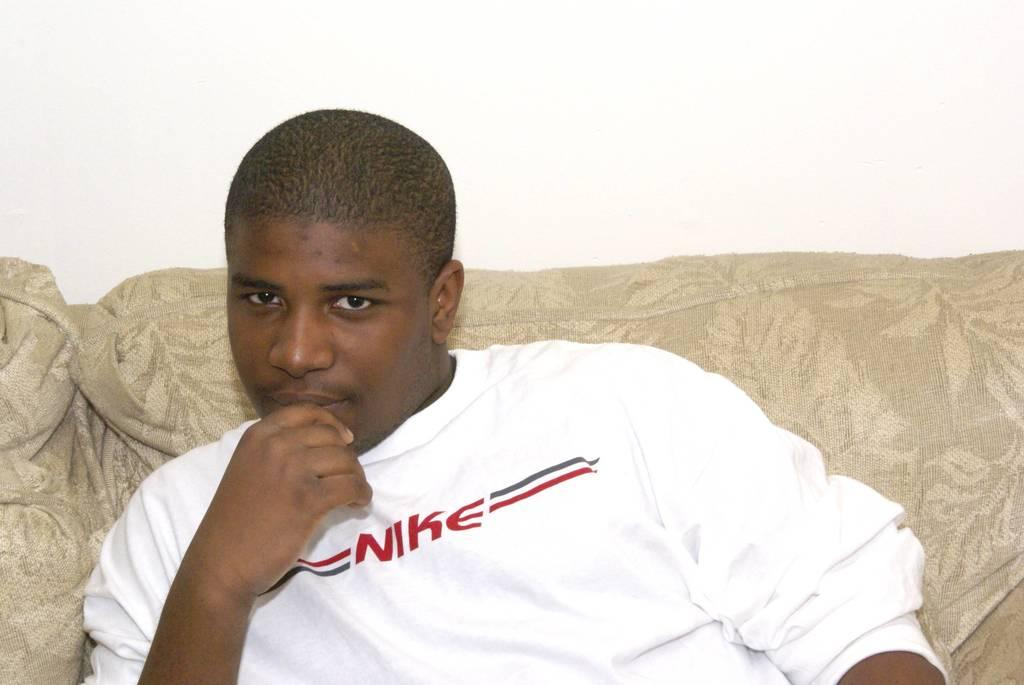<image>
Write a terse but informative summary of the picture. Young black male on a sofa dressed in a Nike tee or sweatshirt. 